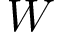Convert formula to latex. <formula><loc_0><loc_0><loc_500><loc_500>W</formula> 